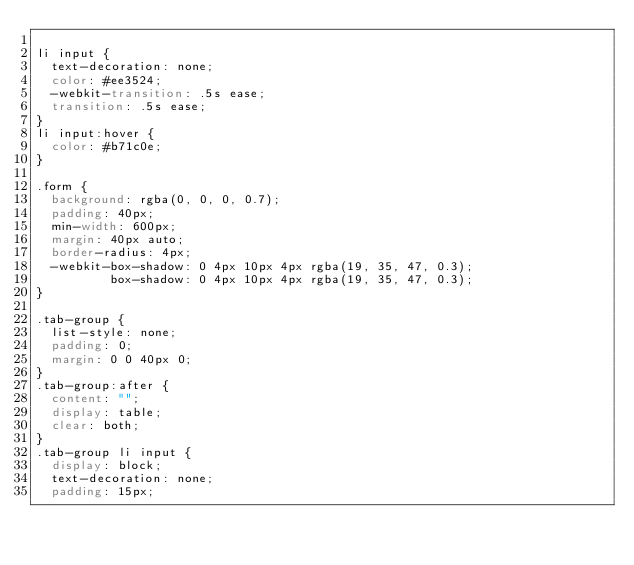<code> <loc_0><loc_0><loc_500><loc_500><_CSS_>
li input {
  text-decoration: none;
  color: #ee3524;
  -webkit-transition: .5s ease;
  transition: .5s ease;
}
li input:hover {
  color: #b71c0e;
}

.form {
  background: rgba(0, 0, 0, 0.7);
  padding: 40px;
  min-width: 600px;
  margin: 40px auto;
  border-radius: 4px;
  -webkit-box-shadow: 0 4px 10px 4px rgba(19, 35, 47, 0.3);
          box-shadow: 0 4px 10px 4px rgba(19, 35, 47, 0.3);
}

.tab-group {
  list-style: none;
  padding: 0;
  margin: 0 0 40px 0;
}
.tab-group:after {
  content: "";
  display: table;
  clear: both;
}
.tab-group li input {
  display: block;
  text-decoration: none;
  padding: 15px;</code> 